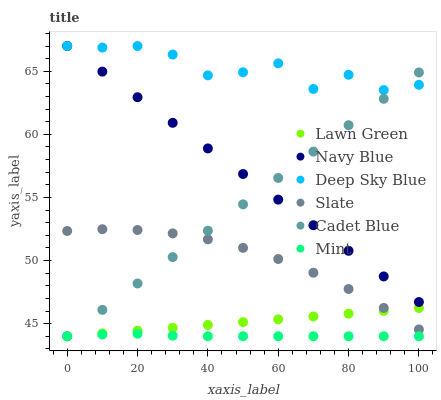Does Mint have the minimum area under the curve?
Answer yes or no. Yes. Does Deep Sky Blue have the maximum area under the curve?
Answer yes or no. Yes. Does Cadet Blue have the minimum area under the curve?
Answer yes or no. No. Does Cadet Blue have the maximum area under the curve?
Answer yes or no. No. Is Cadet Blue the smoothest?
Answer yes or no. Yes. Is Deep Sky Blue the roughest?
Answer yes or no. Yes. Is Navy Blue the smoothest?
Answer yes or no. No. Is Navy Blue the roughest?
Answer yes or no. No. Does Lawn Green have the lowest value?
Answer yes or no. Yes. Does Navy Blue have the lowest value?
Answer yes or no. No. Does Deep Sky Blue have the highest value?
Answer yes or no. Yes. Does Cadet Blue have the highest value?
Answer yes or no. No. Is Mint less than Navy Blue?
Answer yes or no. Yes. Is Slate greater than Mint?
Answer yes or no. Yes. Does Slate intersect Cadet Blue?
Answer yes or no. Yes. Is Slate less than Cadet Blue?
Answer yes or no. No. Is Slate greater than Cadet Blue?
Answer yes or no. No. Does Mint intersect Navy Blue?
Answer yes or no. No. 